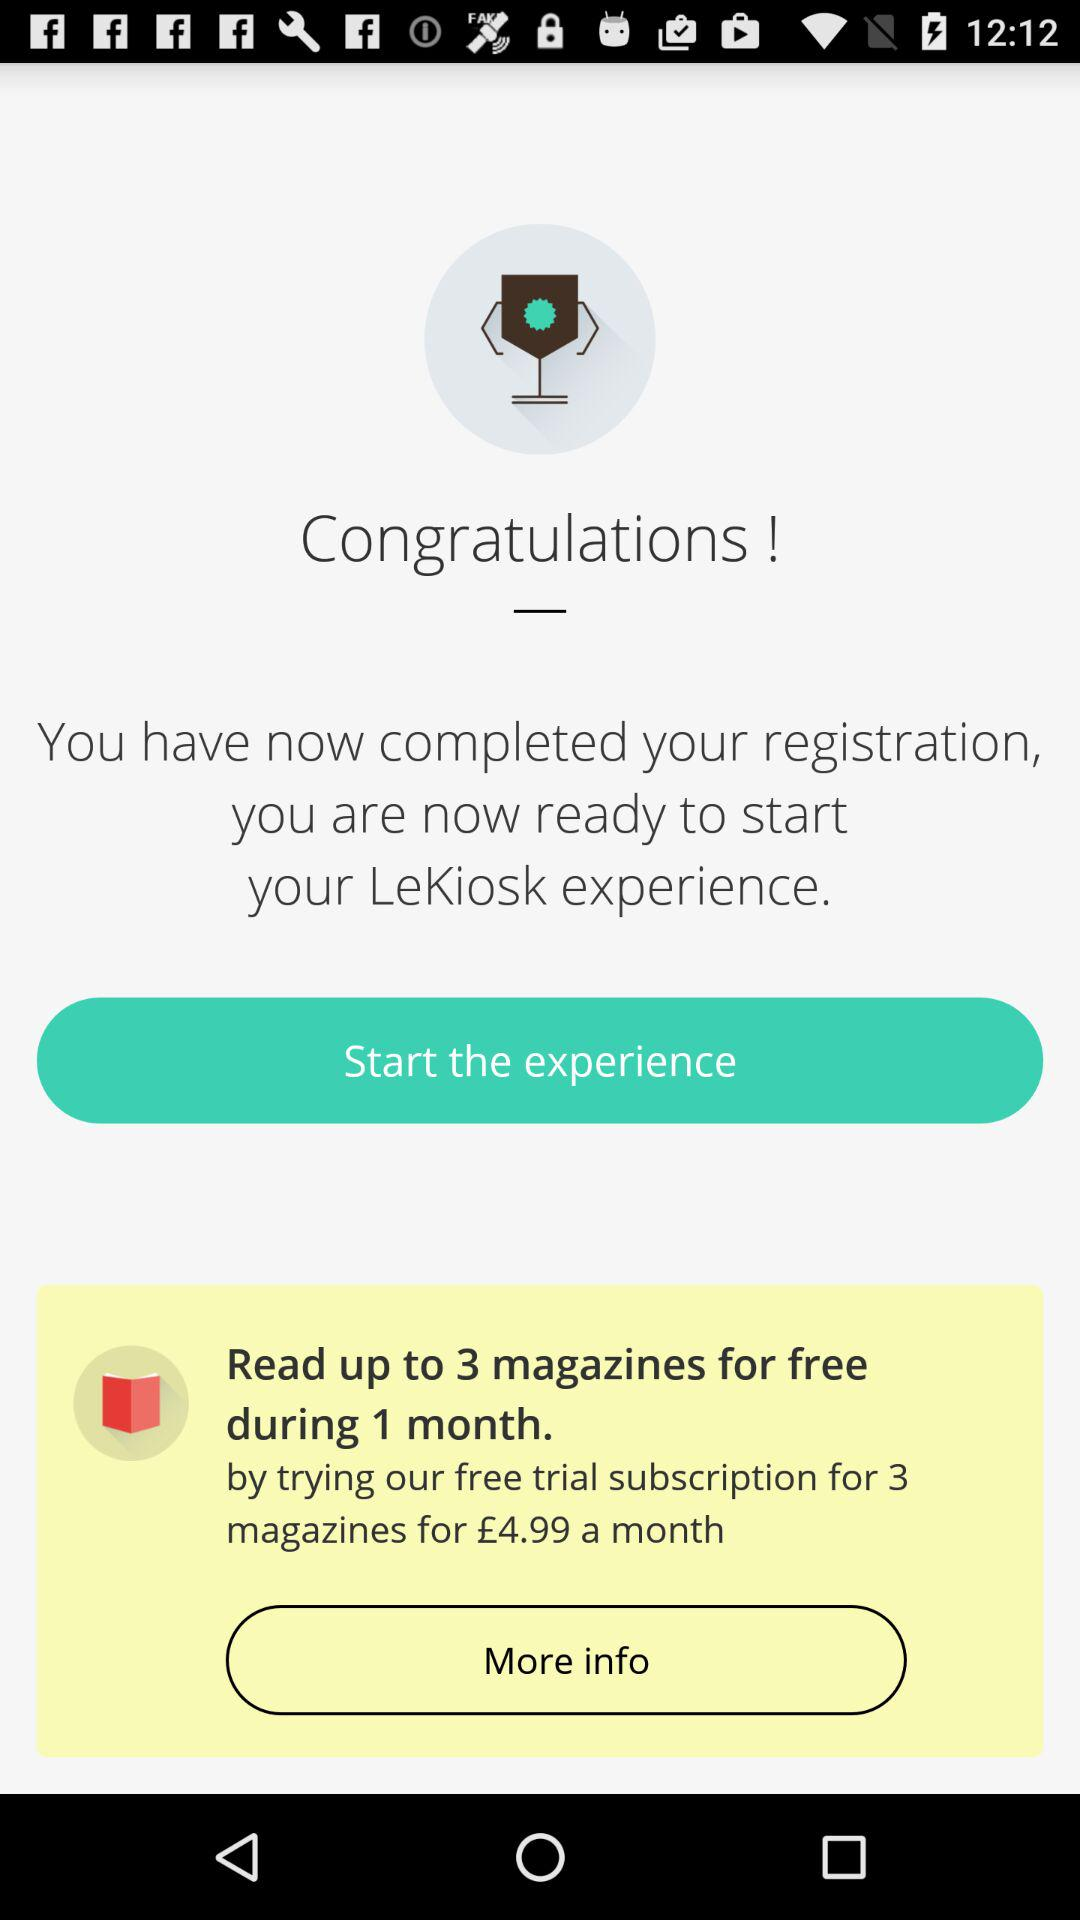What is the monthly subscription price for 3 magazines? The monthly subscription price for 3 magazines is £4.99. 